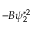<formula> <loc_0><loc_0><loc_500><loc_500>- B \psi _ { 2 } ^ { * 2 }</formula> 